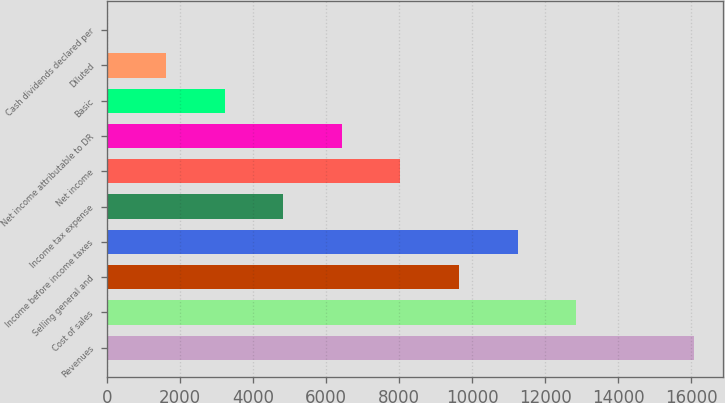Convert chart to OTSL. <chart><loc_0><loc_0><loc_500><loc_500><bar_chart><fcel>Revenues<fcel>Cost of sales<fcel>Selling general and<fcel>Income before income taxes<fcel>Income tax expense<fcel>Net income<fcel>Net income attributable to DR<fcel>Basic<fcel>Diluted<fcel>Cash dividends declared per<nl><fcel>16068<fcel>12854.5<fcel>9641<fcel>11247.8<fcel>4820.75<fcel>8034.25<fcel>6427.5<fcel>3214<fcel>1607.25<fcel>0.5<nl></chart> 